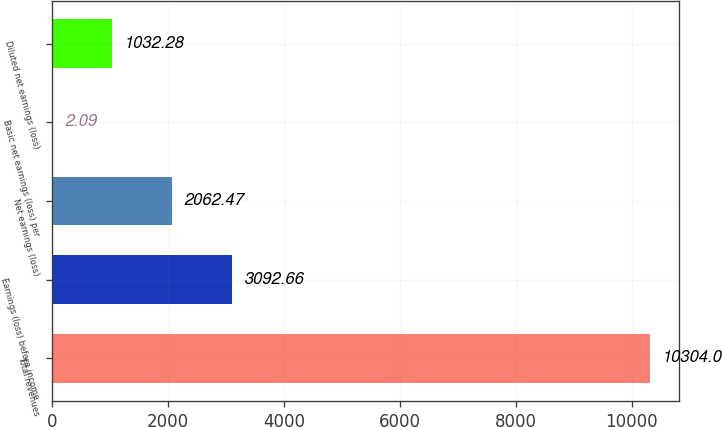<chart> <loc_0><loc_0><loc_500><loc_500><bar_chart><fcel>Total revenues<fcel>Earnings (loss) before income<fcel>Net earnings (loss)<fcel>Basic net earnings (loss) per<fcel>Diluted net earnings (loss)<nl><fcel>10304<fcel>3092.66<fcel>2062.47<fcel>2.09<fcel>1032.28<nl></chart> 